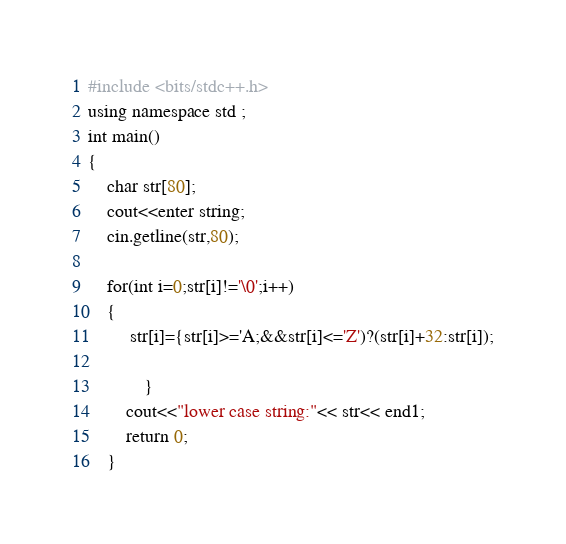Convert code to text. <code><loc_0><loc_0><loc_500><loc_500><_C++_>#include <bits/stdc++.h>
using namespace std ;
int main()
{
	char str[80];
	cout<<enter string;
	cin.getline(str,80);
	 
	for(int i=0;str[i]!='\0';i++)
	{
		 str[i]={str[i]>='A;&&str[i]<='Z')?(str[i]+32:str[i]);

			}
		cout<<"lower case string:"<< str<< end1;
		return 0;
	}
</code> 